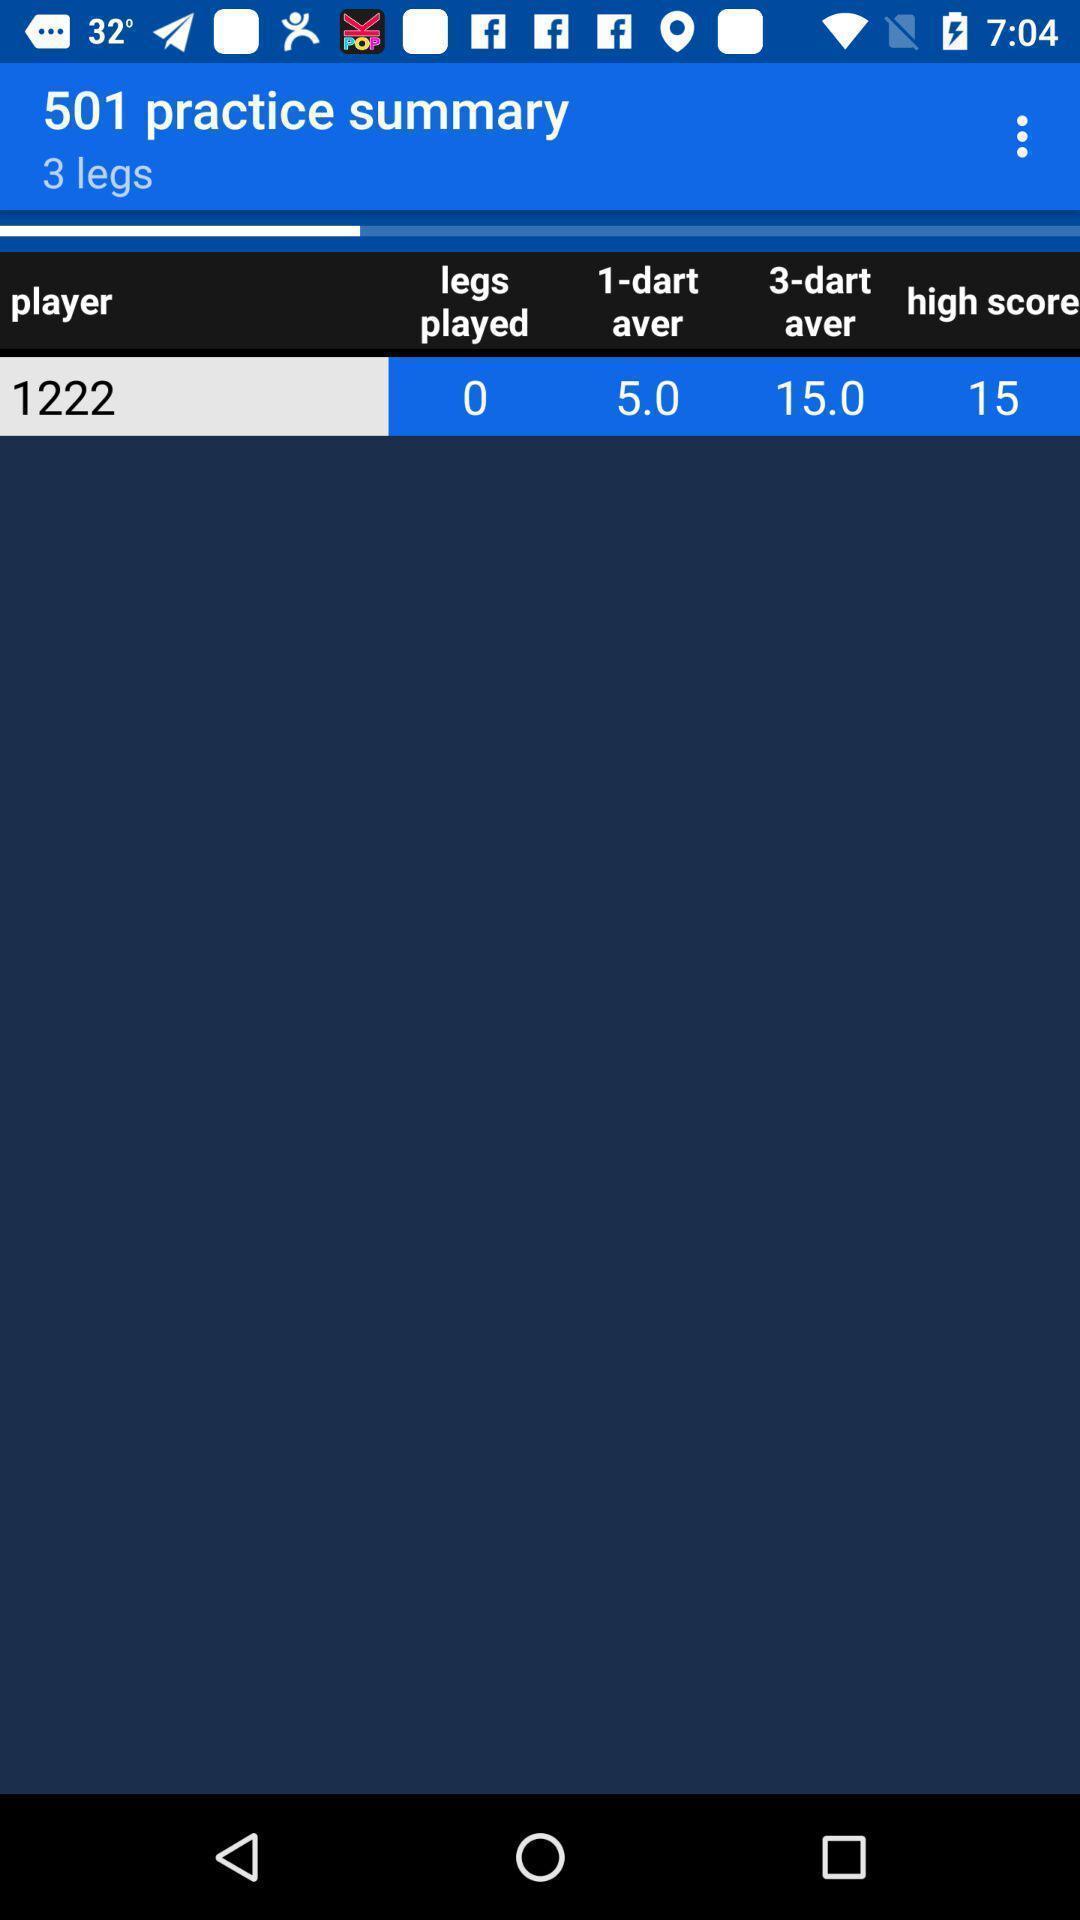Tell me what you see in this picture. Screen showing player details. 